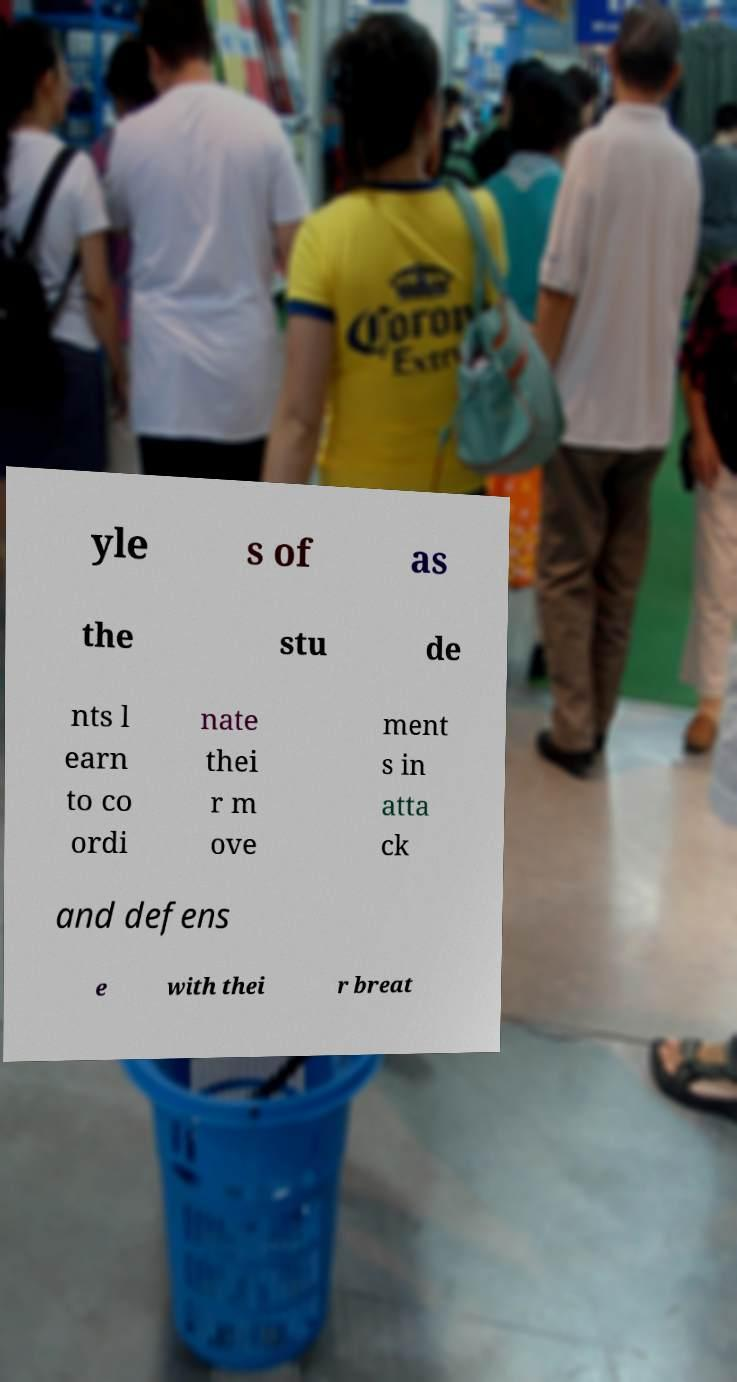Can you read and provide the text displayed in the image?This photo seems to have some interesting text. Can you extract and type it out for me? yle s of as the stu de nts l earn to co ordi nate thei r m ove ment s in atta ck and defens e with thei r breat 